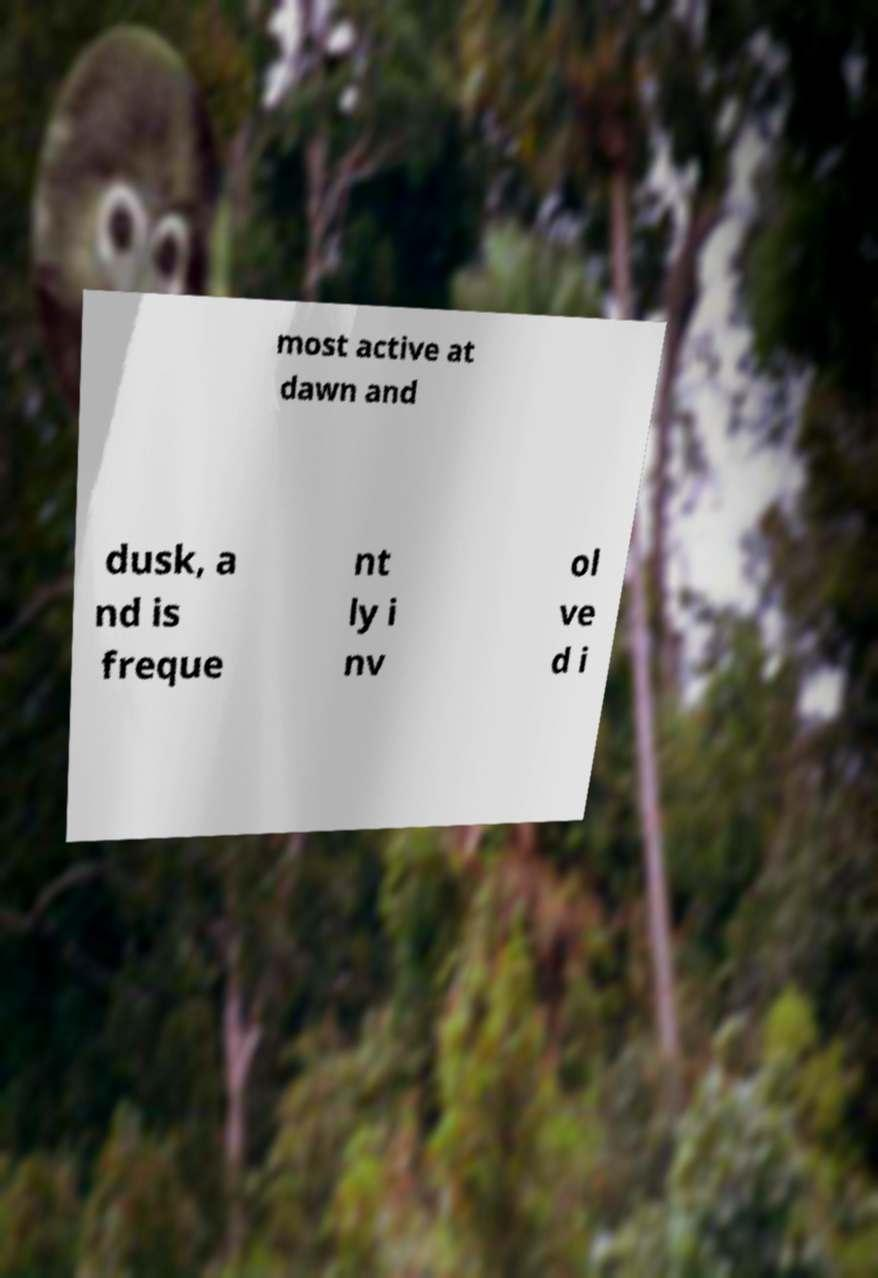There's text embedded in this image that I need extracted. Can you transcribe it verbatim? most active at dawn and dusk, a nd is freque nt ly i nv ol ve d i 